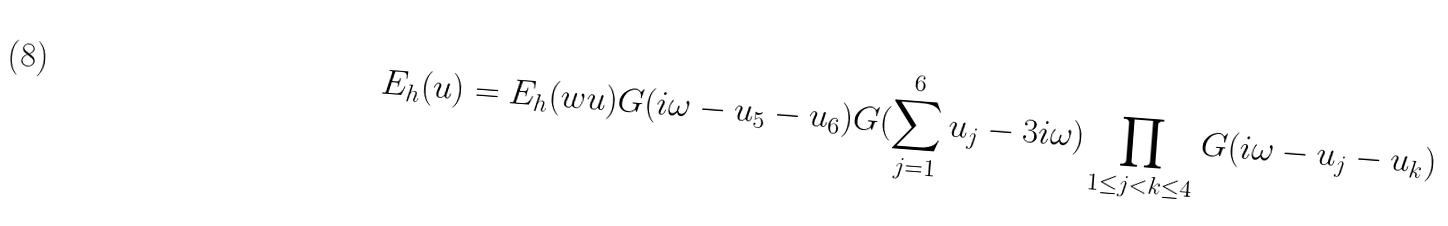Convert formula to latex. <formula><loc_0><loc_0><loc_500><loc_500>E _ { h } ( u ) = E _ { h } ( w u ) G ( i \omega - u _ { 5 } - u _ { 6 } ) G ( \sum _ { j = 1 } ^ { 6 } u _ { j } - 3 i \omega ) \prod _ { 1 \leq j < k \leq 4 } G ( i \omega - u _ { j } - u _ { k } )</formula> 